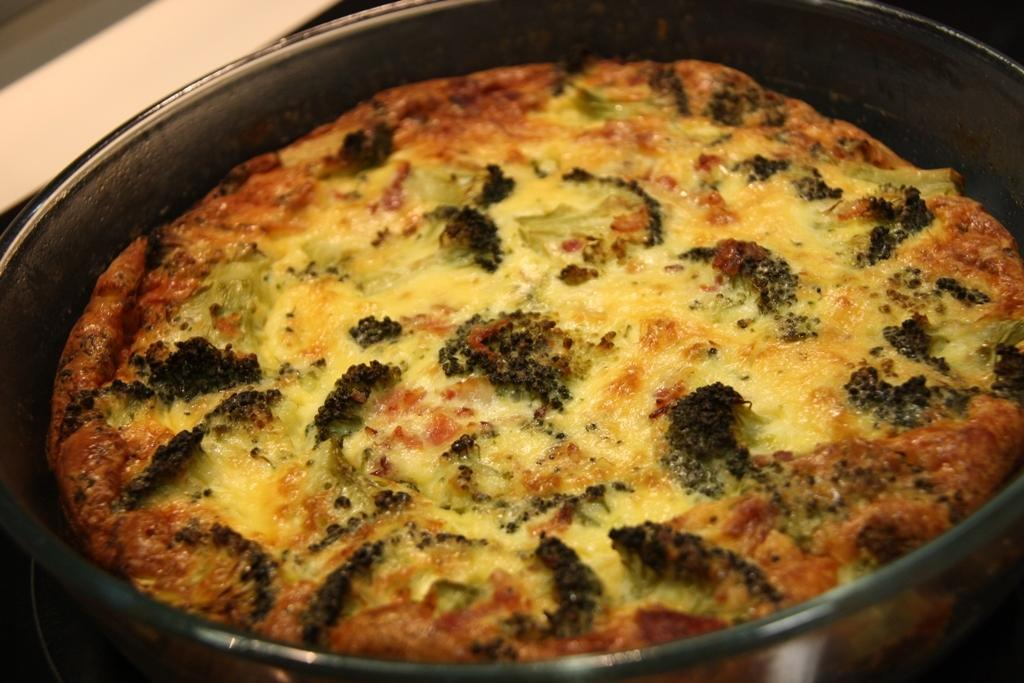What is in the bowl that is visible in the image? There is a bowl with food in the image. What direction is the wind blowing in the image? There is no wind present in the image; it only shows a bowl with food. What shape is the food in the bowl? The shape of the food in the bowl cannot be determined from the image alone, as it is not clear enough to discern the shape of the food. 